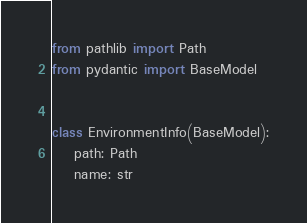Convert code to text. <code><loc_0><loc_0><loc_500><loc_500><_Python_>from pathlib import Path
from pydantic import BaseModel


class EnvironmentInfo(BaseModel):
    path: Path
    name: str
</code> 